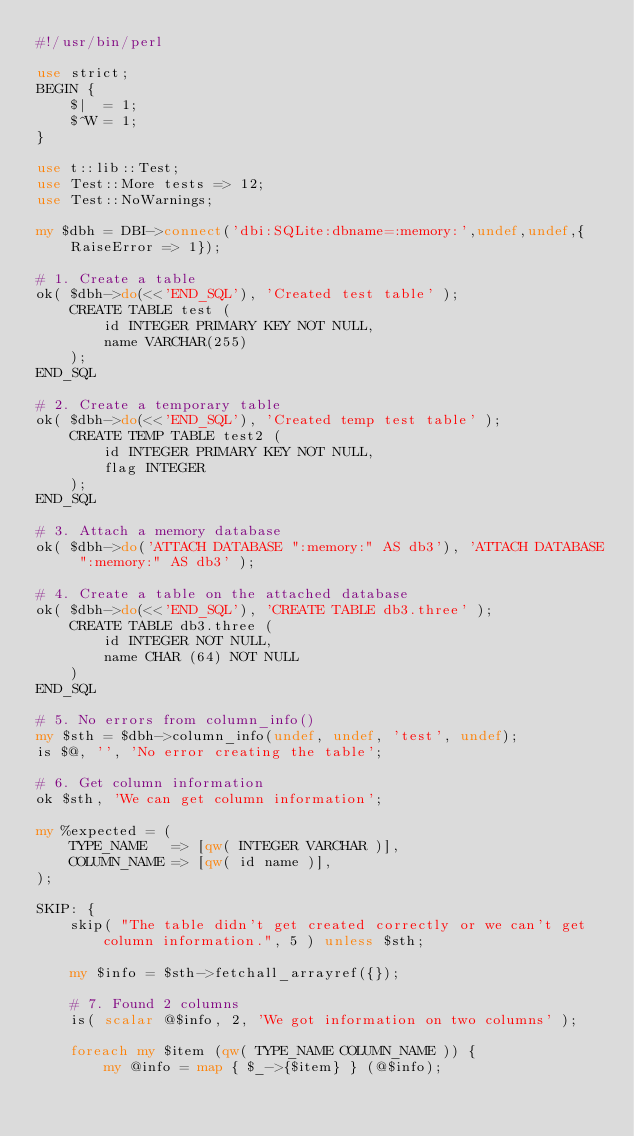<code> <loc_0><loc_0><loc_500><loc_500><_Perl_>#!/usr/bin/perl

use strict;
BEGIN {
	$|  = 1;
	$^W = 1;
}

use t::lib::Test;
use Test::More tests => 12;
use Test::NoWarnings;

my $dbh = DBI->connect('dbi:SQLite:dbname=:memory:',undef,undef,{RaiseError => 1});

# 1. Create a table
ok( $dbh->do(<<'END_SQL'), 'Created test table' );
    CREATE TABLE test (
        id INTEGER PRIMARY KEY NOT NULL,
        name VARCHAR(255)
    );
END_SQL

# 2. Create a temporary table
ok( $dbh->do(<<'END_SQL'), 'Created temp test table' );
    CREATE TEMP TABLE test2 (
        id INTEGER PRIMARY KEY NOT NULL,
        flag INTEGER
    );
END_SQL

# 3. Attach a memory database
ok( $dbh->do('ATTACH DATABASE ":memory:" AS db3'), 'ATTACH DATABASE ":memory:" AS db3' );

# 4. Create a table on the attached database
ok( $dbh->do(<<'END_SQL'), 'CREATE TABLE db3.three' );
    CREATE TABLE db3.three (
        id INTEGER NOT NULL,
        name CHAR (64) NOT NULL
    )
END_SQL

# 5. No errors from column_info()
my $sth = $dbh->column_info(undef, undef, 'test', undef);
is $@, '', 'No error creating the table';

# 6. Get column information
ok $sth, 'We can get column information';

my %expected = (
    TYPE_NAME   => [qw( INTEGER VARCHAR )],
    COLUMN_NAME => [qw( id name )],
);

SKIP: {
    skip( "The table didn't get created correctly or we can't get column information.", 5 ) unless $sth;

    my $info = $sth->fetchall_arrayref({});

    # 7. Found 2 columns
    is( scalar @$info, 2, 'We got information on two columns' );

    foreach my $item (qw( TYPE_NAME COLUMN_NAME )) {
        my @info = map { $_->{$item} } (@$info);</code> 